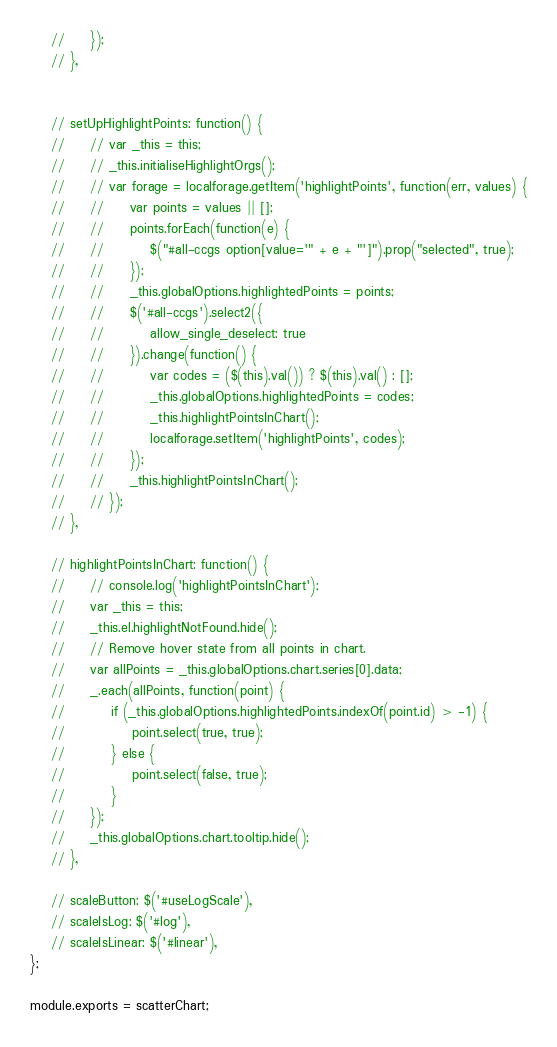Convert code to text. <code><loc_0><loc_0><loc_500><loc_500><_JavaScript_>    //     });
    // },


    // setUpHighlightPoints: function() {
    //     // var _this = this;
    //     // _this.initialiseHighlightOrgs();
    //     // var forage = localforage.getItem('highlightPoints', function(err, values) {
    //     //     var points = values || [];
    //     //     points.forEach(function(e) {
    //     //         $("#all-ccgs option[value='" + e + "']").prop("selected", true);
    //     //     });
    //     //     _this.globalOptions.highlightedPoints = points;
    //     //     $('#all-ccgs').select2({
    //     //         allow_single_deselect: true
    //     //     }).change(function() {
    //     //         var codes = ($(this).val()) ? $(this).val() : [];
    //     //         _this.globalOptions.highlightedPoints = codes;
    //     //         _this.highlightPointsInChart();
    //     //         localforage.setItem('highlightPoints', codes);
    //     //     });
    //     //     _this.highlightPointsInChart();
    //     // });
    // },

    // highlightPointsInChart: function() {
    //     // console.log('highlightPointsInChart');
    //     var _this = this;
    //     _this.el.highlightNotFound.hide();
    //     // Remove hover state from all points in chart.
    //     var allPoints = _this.globalOptions.chart.series[0].data;
    //     _.each(allPoints, function(point) {
    //         if (_this.globalOptions.highlightedPoints.indexOf(point.id) > -1) {
    //             point.select(true, true);
    //         } else {
    //             point.select(false, true);
    //         }
    //     });
    //     _this.globalOptions.chart.tooltip.hide();
    // },

    // scaleButton: $('#useLogScale'),
    // scaleIsLog: $('#log'),
    // scaleIsLinear: $('#linear'),
};

module.exports = scatterChart;
</code> 